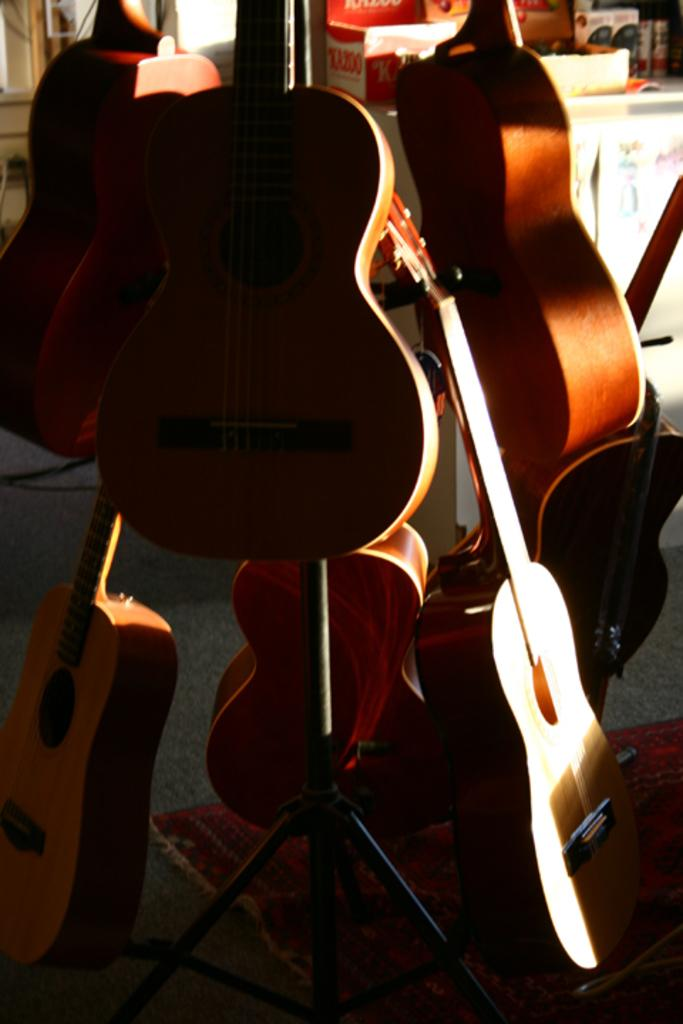What musical instruments are present in the image? There are guitars in the image. What type of furniture is visible in the image? There is a table in the image. What objects are placed on the table? There are boxes on the table. What type of secretary is sitting next to the guitars in the image? There is no secretary present in the image; it only features guitars, a table, and boxes. 